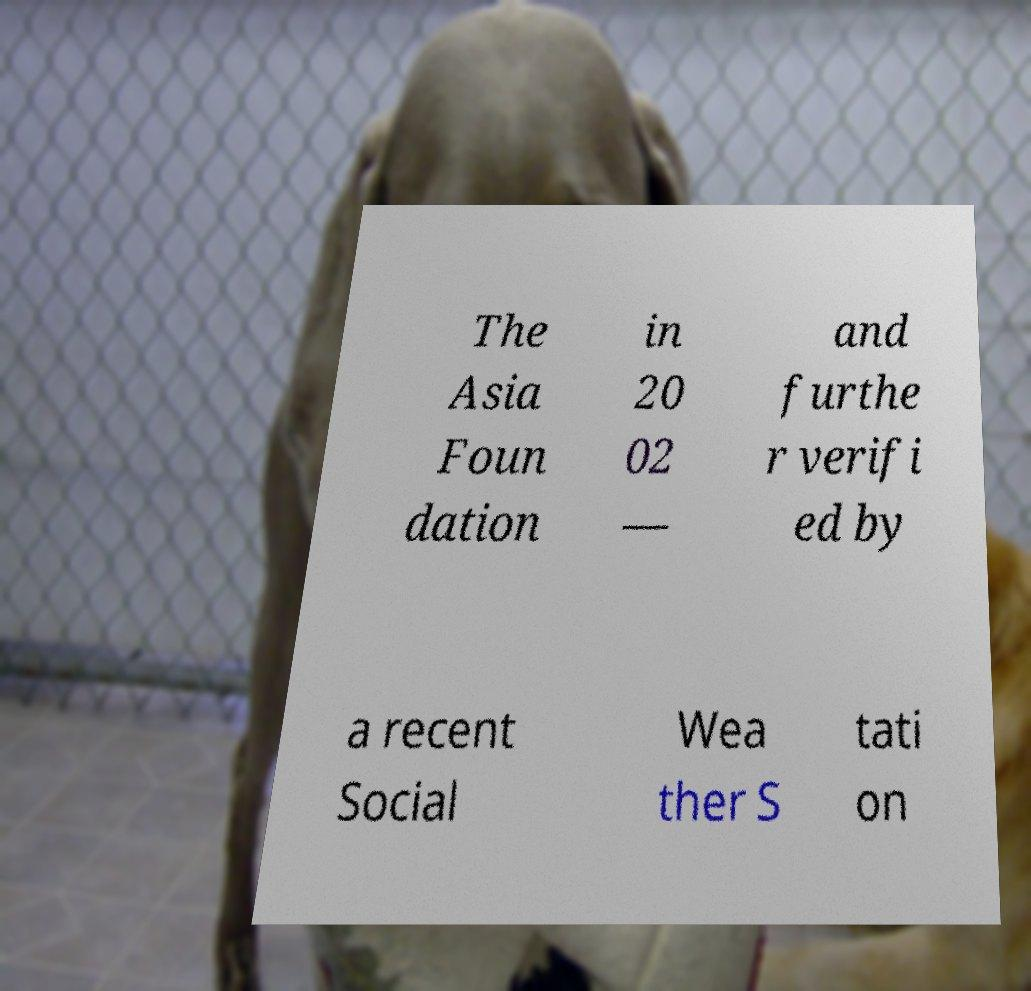I need the written content from this picture converted into text. Can you do that? The Asia Foun dation in 20 02 — and furthe r verifi ed by a recent Social Wea ther S tati on 